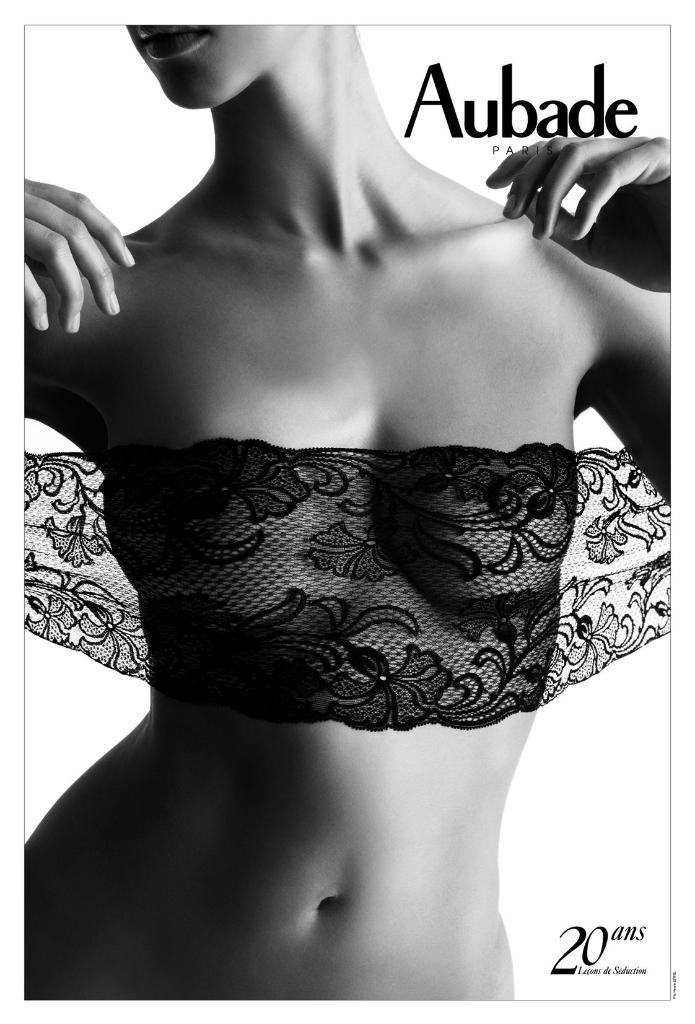What is the color scheme of the image? The image is black and white. Who or what is the main subject of the image? There is a woman in the image. Are there any visible marks or patterns in the image? Yes, there are watermarks on the right side of the image. What type of argument is the woman having with the beds in the image? There are no beds present in the image, and therefore no argument can be observed. 